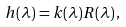<formula> <loc_0><loc_0><loc_500><loc_500>h ( \lambda ) = k ( \lambda ) R ( \lambda ) \, ,</formula> 